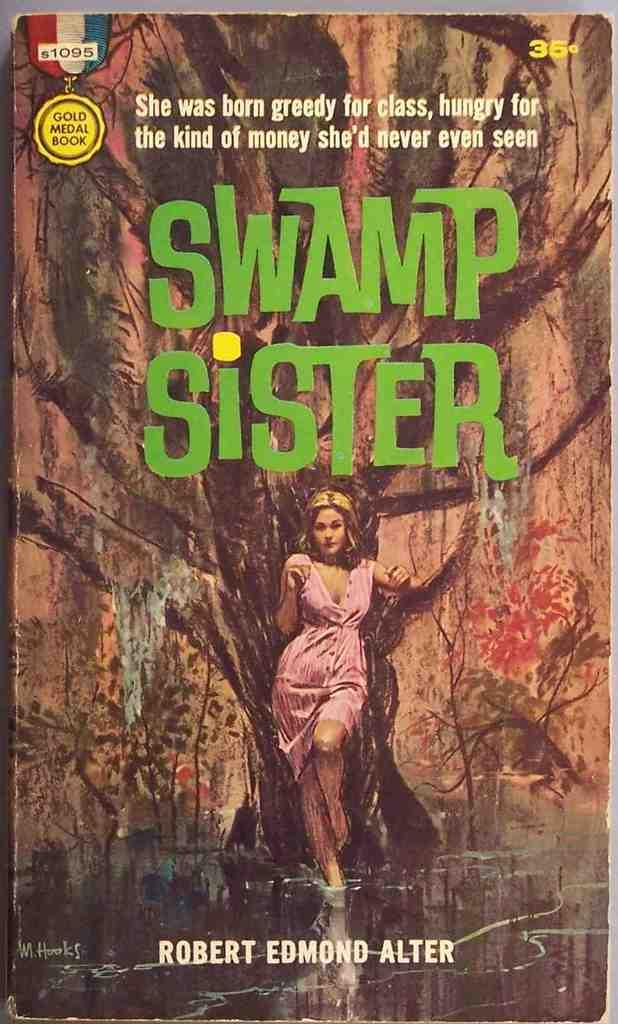<image>
Share a concise interpretation of the image provided. The cover of a book, the book's title is Swamp sister. 